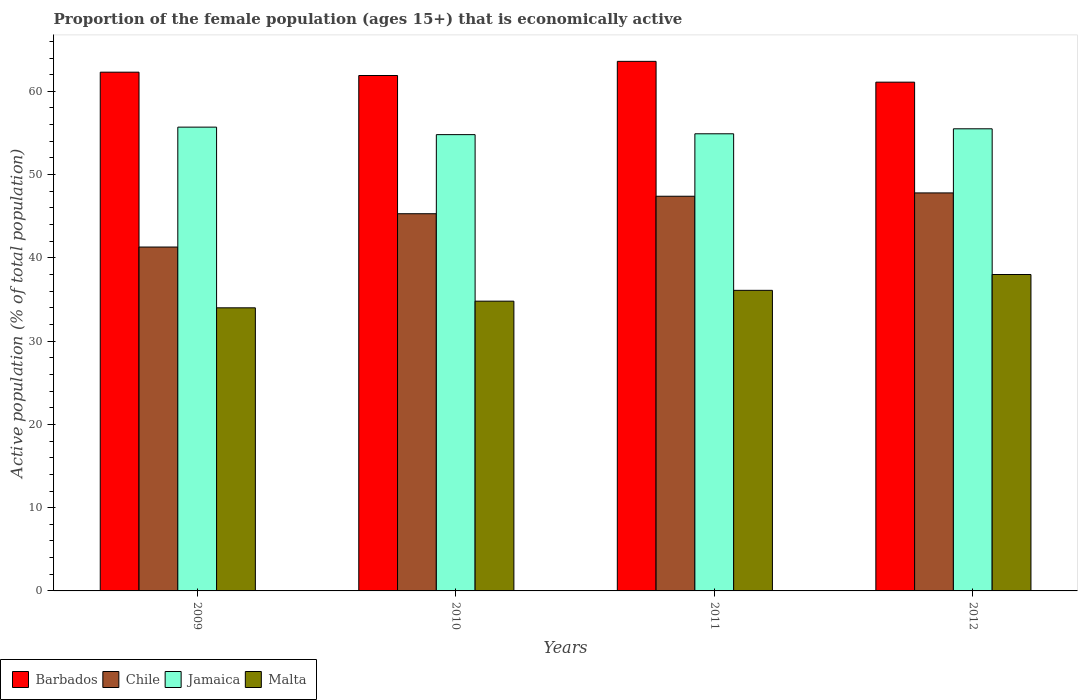How many groups of bars are there?
Give a very brief answer. 4. Are the number of bars on each tick of the X-axis equal?
Your answer should be compact. Yes. How many bars are there on the 2nd tick from the right?
Your answer should be compact. 4. What is the label of the 1st group of bars from the left?
Provide a short and direct response. 2009. What is the proportion of the female population that is economically active in Barbados in 2010?
Keep it short and to the point. 61.9. Across all years, what is the maximum proportion of the female population that is economically active in Jamaica?
Keep it short and to the point. 55.7. Across all years, what is the minimum proportion of the female population that is economically active in Barbados?
Provide a succinct answer. 61.1. In which year was the proportion of the female population that is economically active in Chile maximum?
Make the answer very short. 2012. What is the total proportion of the female population that is economically active in Jamaica in the graph?
Offer a terse response. 220.9. What is the difference between the proportion of the female population that is economically active in Barbados in 2009 and that in 2011?
Ensure brevity in your answer.  -1.3. What is the difference between the proportion of the female population that is economically active in Malta in 2011 and the proportion of the female population that is economically active in Chile in 2010?
Ensure brevity in your answer.  -9.2. What is the average proportion of the female population that is economically active in Jamaica per year?
Keep it short and to the point. 55.23. In the year 2009, what is the difference between the proportion of the female population that is economically active in Barbados and proportion of the female population that is economically active in Jamaica?
Your answer should be very brief. 6.6. What is the ratio of the proportion of the female population that is economically active in Malta in 2009 to that in 2012?
Offer a terse response. 0.89. Is the proportion of the female population that is economically active in Chile in 2010 less than that in 2012?
Your answer should be compact. Yes. What is the difference between the highest and the second highest proportion of the female population that is economically active in Barbados?
Keep it short and to the point. 1.3. What is the difference between the highest and the lowest proportion of the female population that is economically active in Malta?
Offer a terse response. 4. Is the sum of the proportion of the female population that is economically active in Barbados in 2011 and 2012 greater than the maximum proportion of the female population that is economically active in Malta across all years?
Make the answer very short. Yes. What does the 1st bar from the left in 2012 represents?
Offer a very short reply. Barbados. What does the 1st bar from the right in 2011 represents?
Provide a succinct answer. Malta. Is it the case that in every year, the sum of the proportion of the female population that is economically active in Malta and proportion of the female population that is economically active in Chile is greater than the proportion of the female population that is economically active in Barbados?
Your answer should be very brief. Yes. Are all the bars in the graph horizontal?
Provide a short and direct response. No. How many years are there in the graph?
Provide a succinct answer. 4. What is the difference between two consecutive major ticks on the Y-axis?
Make the answer very short. 10. Where does the legend appear in the graph?
Provide a short and direct response. Bottom left. What is the title of the graph?
Make the answer very short. Proportion of the female population (ages 15+) that is economically active. What is the label or title of the X-axis?
Your response must be concise. Years. What is the label or title of the Y-axis?
Ensure brevity in your answer.  Active population (% of total population). What is the Active population (% of total population) of Barbados in 2009?
Give a very brief answer. 62.3. What is the Active population (% of total population) of Chile in 2009?
Give a very brief answer. 41.3. What is the Active population (% of total population) of Jamaica in 2009?
Offer a very short reply. 55.7. What is the Active population (% of total population) in Malta in 2009?
Your answer should be compact. 34. What is the Active population (% of total population) of Barbados in 2010?
Ensure brevity in your answer.  61.9. What is the Active population (% of total population) in Chile in 2010?
Keep it short and to the point. 45.3. What is the Active population (% of total population) in Jamaica in 2010?
Your answer should be very brief. 54.8. What is the Active population (% of total population) in Malta in 2010?
Keep it short and to the point. 34.8. What is the Active population (% of total population) in Barbados in 2011?
Make the answer very short. 63.6. What is the Active population (% of total population) of Chile in 2011?
Provide a short and direct response. 47.4. What is the Active population (% of total population) of Jamaica in 2011?
Ensure brevity in your answer.  54.9. What is the Active population (% of total population) of Malta in 2011?
Provide a short and direct response. 36.1. What is the Active population (% of total population) in Barbados in 2012?
Provide a short and direct response. 61.1. What is the Active population (% of total population) of Chile in 2012?
Provide a short and direct response. 47.8. What is the Active population (% of total population) in Jamaica in 2012?
Ensure brevity in your answer.  55.5. Across all years, what is the maximum Active population (% of total population) in Barbados?
Your response must be concise. 63.6. Across all years, what is the maximum Active population (% of total population) of Chile?
Your answer should be compact. 47.8. Across all years, what is the maximum Active population (% of total population) of Jamaica?
Provide a succinct answer. 55.7. Across all years, what is the minimum Active population (% of total population) of Barbados?
Your answer should be very brief. 61.1. Across all years, what is the minimum Active population (% of total population) of Chile?
Give a very brief answer. 41.3. Across all years, what is the minimum Active population (% of total population) of Jamaica?
Provide a short and direct response. 54.8. What is the total Active population (% of total population) of Barbados in the graph?
Give a very brief answer. 248.9. What is the total Active population (% of total population) of Chile in the graph?
Offer a terse response. 181.8. What is the total Active population (% of total population) of Jamaica in the graph?
Keep it short and to the point. 220.9. What is the total Active population (% of total population) in Malta in the graph?
Offer a very short reply. 142.9. What is the difference between the Active population (% of total population) in Barbados in 2009 and that in 2010?
Your answer should be very brief. 0.4. What is the difference between the Active population (% of total population) of Chile in 2009 and that in 2010?
Give a very brief answer. -4. What is the difference between the Active population (% of total population) of Jamaica in 2009 and that in 2010?
Your answer should be very brief. 0.9. What is the difference between the Active population (% of total population) of Chile in 2009 and that in 2011?
Your response must be concise. -6.1. What is the difference between the Active population (% of total population) in Jamaica in 2009 and that in 2011?
Make the answer very short. 0.8. What is the difference between the Active population (% of total population) of Malta in 2009 and that in 2011?
Provide a short and direct response. -2.1. What is the difference between the Active population (% of total population) of Chile in 2009 and that in 2012?
Your response must be concise. -6.5. What is the difference between the Active population (% of total population) in Jamaica in 2009 and that in 2012?
Your answer should be very brief. 0.2. What is the difference between the Active population (% of total population) of Malta in 2009 and that in 2012?
Keep it short and to the point. -4. What is the difference between the Active population (% of total population) in Barbados in 2010 and that in 2011?
Give a very brief answer. -1.7. What is the difference between the Active population (% of total population) in Malta in 2010 and that in 2011?
Offer a terse response. -1.3. What is the difference between the Active population (% of total population) in Barbados in 2010 and that in 2012?
Your response must be concise. 0.8. What is the difference between the Active population (% of total population) of Malta in 2010 and that in 2012?
Keep it short and to the point. -3.2. What is the difference between the Active population (% of total population) in Jamaica in 2011 and that in 2012?
Provide a short and direct response. -0.6. What is the difference between the Active population (% of total population) in Malta in 2011 and that in 2012?
Your response must be concise. -1.9. What is the difference between the Active population (% of total population) in Barbados in 2009 and the Active population (% of total population) in Chile in 2010?
Make the answer very short. 17. What is the difference between the Active population (% of total population) in Barbados in 2009 and the Active population (% of total population) in Jamaica in 2010?
Make the answer very short. 7.5. What is the difference between the Active population (% of total population) of Barbados in 2009 and the Active population (% of total population) of Malta in 2010?
Keep it short and to the point. 27.5. What is the difference between the Active population (% of total population) of Chile in 2009 and the Active population (% of total population) of Jamaica in 2010?
Your answer should be very brief. -13.5. What is the difference between the Active population (% of total population) in Jamaica in 2009 and the Active population (% of total population) in Malta in 2010?
Provide a short and direct response. 20.9. What is the difference between the Active population (% of total population) in Barbados in 2009 and the Active population (% of total population) in Jamaica in 2011?
Keep it short and to the point. 7.4. What is the difference between the Active population (% of total population) of Barbados in 2009 and the Active population (% of total population) of Malta in 2011?
Give a very brief answer. 26.2. What is the difference between the Active population (% of total population) of Chile in 2009 and the Active population (% of total population) of Jamaica in 2011?
Offer a terse response. -13.6. What is the difference between the Active population (% of total population) of Chile in 2009 and the Active population (% of total population) of Malta in 2011?
Provide a succinct answer. 5.2. What is the difference between the Active population (% of total population) in Jamaica in 2009 and the Active population (% of total population) in Malta in 2011?
Make the answer very short. 19.6. What is the difference between the Active population (% of total population) in Barbados in 2009 and the Active population (% of total population) in Chile in 2012?
Your answer should be very brief. 14.5. What is the difference between the Active population (% of total population) of Barbados in 2009 and the Active population (% of total population) of Malta in 2012?
Your response must be concise. 24.3. What is the difference between the Active population (% of total population) of Chile in 2009 and the Active population (% of total population) of Jamaica in 2012?
Offer a very short reply. -14.2. What is the difference between the Active population (% of total population) in Chile in 2009 and the Active population (% of total population) in Malta in 2012?
Offer a terse response. 3.3. What is the difference between the Active population (% of total population) in Jamaica in 2009 and the Active population (% of total population) in Malta in 2012?
Ensure brevity in your answer.  17.7. What is the difference between the Active population (% of total population) of Barbados in 2010 and the Active population (% of total population) of Chile in 2011?
Make the answer very short. 14.5. What is the difference between the Active population (% of total population) of Barbados in 2010 and the Active population (% of total population) of Malta in 2011?
Give a very brief answer. 25.8. What is the difference between the Active population (% of total population) in Chile in 2010 and the Active population (% of total population) in Jamaica in 2011?
Offer a very short reply. -9.6. What is the difference between the Active population (% of total population) in Jamaica in 2010 and the Active population (% of total population) in Malta in 2011?
Keep it short and to the point. 18.7. What is the difference between the Active population (% of total population) in Barbados in 2010 and the Active population (% of total population) in Jamaica in 2012?
Keep it short and to the point. 6.4. What is the difference between the Active population (% of total population) of Barbados in 2010 and the Active population (% of total population) of Malta in 2012?
Your answer should be very brief. 23.9. What is the difference between the Active population (% of total population) in Chile in 2010 and the Active population (% of total population) in Jamaica in 2012?
Provide a short and direct response. -10.2. What is the difference between the Active population (% of total population) in Jamaica in 2010 and the Active population (% of total population) in Malta in 2012?
Offer a terse response. 16.8. What is the difference between the Active population (% of total population) in Barbados in 2011 and the Active population (% of total population) in Jamaica in 2012?
Your answer should be compact. 8.1. What is the difference between the Active population (% of total population) of Barbados in 2011 and the Active population (% of total population) of Malta in 2012?
Your answer should be compact. 25.6. What is the difference between the Active population (% of total population) in Chile in 2011 and the Active population (% of total population) in Malta in 2012?
Offer a terse response. 9.4. What is the difference between the Active population (% of total population) in Jamaica in 2011 and the Active population (% of total population) in Malta in 2012?
Your answer should be very brief. 16.9. What is the average Active population (% of total population) of Barbados per year?
Offer a terse response. 62.23. What is the average Active population (% of total population) of Chile per year?
Ensure brevity in your answer.  45.45. What is the average Active population (% of total population) of Jamaica per year?
Keep it short and to the point. 55.23. What is the average Active population (% of total population) in Malta per year?
Provide a short and direct response. 35.73. In the year 2009, what is the difference between the Active population (% of total population) in Barbados and Active population (% of total population) in Chile?
Give a very brief answer. 21. In the year 2009, what is the difference between the Active population (% of total population) of Barbados and Active population (% of total population) of Jamaica?
Your answer should be compact. 6.6. In the year 2009, what is the difference between the Active population (% of total population) in Barbados and Active population (% of total population) in Malta?
Your response must be concise. 28.3. In the year 2009, what is the difference between the Active population (% of total population) of Chile and Active population (% of total population) of Jamaica?
Ensure brevity in your answer.  -14.4. In the year 2009, what is the difference between the Active population (% of total population) of Chile and Active population (% of total population) of Malta?
Make the answer very short. 7.3. In the year 2009, what is the difference between the Active population (% of total population) of Jamaica and Active population (% of total population) of Malta?
Offer a very short reply. 21.7. In the year 2010, what is the difference between the Active population (% of total population) of Barbados and Active population (% of total population) of Malta?
Your response must be concise. 27.1. In the year 2010, what is the difference between the Active population (% of total population) in Chile and Active population (% of total population) in Jamaica?
Provide a short and direct response. -9.5. In the year 2010, what is the difference between the Active population (% of total population) of Jamaica and Active population (% of total population) of Malta?
Keep it short and to the point. 20. In the year 2011, what is the difference between the Active population (% of total population) in Barbados and Active population (% of total population) in Chile?
Your response must be concise. 16.2. In the year 2011, what is the difference between the Active population (% of total population) in Barbados and Active population (% of total population) in Malta?
Provide a short and direct response. 27.5. In the year 2011, what is the difference between the Active population (% of total population) in Jamaica and Active population (% of total population) in Malta?
Your answer should be compact. 18.8. In the year 2012, what is the difference between the Active population (% of total population) of Barbados and Active population (% of total population) of Chile?
Your answer should be very brief. 13.3. In the year 2012, what is the difference between the Active population (% of total population) of Barbados and Active population (% of total population) of Jamaica?
Your answer should be very brief. 5.6. In the year 2012, what is the difference between the Active population (% of total population) of Barbados and Active population (% of total population) of Malta?
Provide a succinct answer. 23.1. In the year 2012, what is the difference between the Active population (% of total population) in Chile and Active population (% of total population) in Jamaica?
Keep it short and to the point. -7.7. In the year 2012, what is the difference between the Active population (% of total population) in Chile and Active population (% of total population) in Malta?
Offer a terse response. 9.8. What is the ratio of the Active population (% of total population) in Chile in 2009 to that in 2010?
Offer a very short reply. 0.91. What is the ratio of the Active population (% of total population) in Jamaica in 2009 to that in 2010?
Your response must be concise. 1.02. What is the ratio of the Active population (% of total population) in Malta in 2009 to that in 2010?
Ensure brevity in your answer.  0.98. What is the ratio of the Active population (% of total population) in Barbados in 2009 to that in 2011?
Your answer should be very brief. 0.98. What is the ratio of the Active population (% of total population) in Chile in 2009 to that in 2011?
Your response must be concise. 0.87. What is the ratio of the Active population (% of total population) in Jamaica in 2009 to that in 2011?
Give a very brief answer. 1.01. What is the ratio of the Active population (% of total population) in Malta in 2009 to that in 2011?
Your response must be concise. 0.94. What is the ratio of the Active population (% of total population) in Barbados in 2009 to that in 2012?
Your response must be concise. 1.02. What is the ratio of the Active population (% of total population) in Chile in 2009 to that in 2012?
Offer a very short reply. 0.86. What is the ratio of the Active population (% of total population) in Malta in 2009 to that in 2012?
Offer a terse response. 0.89. What is the ratio of the Active population (% of total population) in Barbados in 2010 to that in 2011?
Your response must be concise. 0.97. What is the ratio of the Active population (% of total population) in Chile in 2010 to that in 2011?
Give a very brief answer. 0.96. What is the ratio of the Active population (% of total population) of Malta in 2010 to that in 2011?
Your answer should be very brief. 0.96. What is the ratio of the Active population (% of total population) in Barbados in 2010 to that in 2012?
Offer a very short reply. 1.01. What is the ratio of the Active population (% of total population) in Chile in 2010 to that in 2012?
Provide a succinct answer. 0.95. What is the ratio of the Active population (% of total population) of Jamaica in 2010 to that in 2012?
Your response must be concise. 0.99. What is the ratio of the Active population (% of total population) in Malta in 2010 to that in 2012?
Provide a succinct answer. 0.92. What is the ratio of the Active population (% of total population) of Barbados in 2011 to that in 2012?
Offer a terse response. 1.04. What is the ratio of the Active population (% of total population) of Chile in 2011 to that in 2012?
Provide a succinct answer. 0.99. What is the ratio of the Active population (% of total population) in Jamaica in 2011 to that in 2012?
Ensure brevity in your answer.  0.99. What is the ratio of the Active population (% of total population) of Malta in 2011 to that in 2012?
Your answer should be very brief. 0.95. What is the difference between the highest and the second highest Active population (% of total population) in Chile?
Offer a very short reply. 0.4. What is the difference between the highest and the second highest Active population (% of total population) in Malta?
Offer a terse response. 1.9. What is the difference between the highest and the lowest Active population (% of total population) of Barbados?
Keep it short and to the point. 2.5. What is the difference between the highest and the lowest Active population (% of total population) of Chile?
Provide a short and direct response. 6.5. What is the difference between the highest and the lowest Active population (% of total population) in Jamaica?
Provide a short and direct response. 0.9. What is the difference between the highest and the lowest Active population (% of total population) in Malta?
Offer a terse response. 4. 